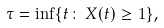<formula> <loc_0><loc_0><loc_500><loc_500>\tau = \inf \{ t \colon \, X ( t ) \geq 1 \} ,</formula> 